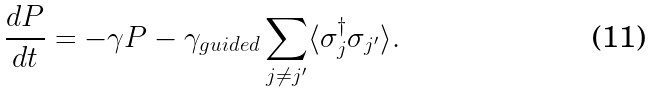Convert formula to latex. <formula><loc_0><loc_0><loc_500><loc_500>\frac { d P } { d t } = - \gamma P - \gamma _ { g u i d e d } \sum _ { j \not = j ^ { \prime } } \langle \sigma _ { j } ^ { \dagger } \sigma _ { j ^ { \prime } } \rangle .</formula> 